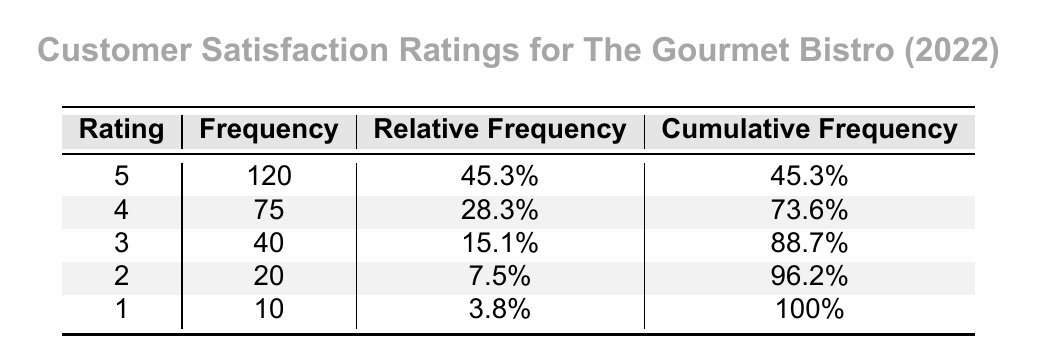What is the frequency of customers who rated the restaurant a 5? According to the table, the frequency of customers who rated the restaurant a 5 is explicitly listed under the "Frequency" column for the rating 5. It shows that 120 customers provided this rating.
Answer: 120 What percentage of customers gave a rating of 4? The relative frequency for the rating of 4 is displayed in the table as 28.3%, indicating that this percentage of customers rated the restaurant a 4.
Answer: 28.3% What is the cumulative frequency for ratings of 2 and below? To find the cumulative frequency for ratings of 2 and below, we look at the cumulative frequencies for rating 2 (96.2%) and rating 1 (100%). Thus, the cumulative frequency for ratings 2 and below is 100% - 96.2% = 3.8%.
Answer: 30 What is the difference in frequency between the highest and lowest ratings? The highest rating is 5 with a frequency of 120, and the lowest rating is 1 with a frequency of 10. Calculating the difference: 120 - 10 = 110.
Answer: 110 Is it true that more than 50% of customers rated the restaurant either 4 or 5? To confirm this, we add the relative frequencies for ratings 4 and 5: 28.3% + 45.3% = 73.6%. Since 73.6% is greater than 50%, the statement is true.
Answer: Yes What is the average customer satisfaction rating based on the frequency data? To calculate the average rating, we use the formula: (5*120 + 4*75 + 3*40 + 2*20 + 1*10) / (120 + 75 + 40 + 20 + 10). First, we calculate the total score: (600 + 300 + 120 + 40 + 10 = 1070), then the total number of ratings, which is 120 + 75 + 40 + 20 + 10 = 265. Thus, the average rating is 1070 / 265 ≈ 4.04.
Answer: 4.04 How many customers rated the restaurant with a score of 3 or higher? To find this, we need to sum the frequencies of the ratings 3, 4, and 5: 40 (rating 3) + 75 (rating 4) + 120 (rating 5) = 235.
Answer: 235 How many customers rated the restaurant a score of less than 3? We add the frequencies of ratings less than 3, which are ratings 1 and 2: 10 (for rating 1) + 20 (for rating 2) = 30.
Answer: 30 What proportion of customers rated the restaurant a score of 4 or lower? To find the proportion, we add the frequencies for ratings 1, 2, 3, and 4: 10 + 20 + 40 + 75 = 145. Now, calculating the proportion: 145 / 265 (total responses) = 0.547. Thus, the proportion is approximately 54.7%.
Answer: 54.7% 